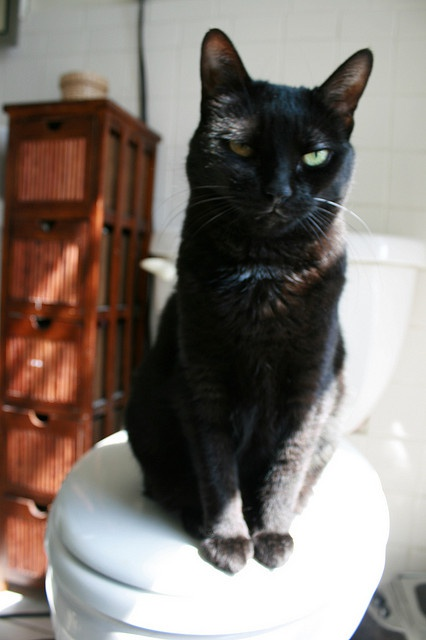Describe the objects in this image and their specific colors. I can see cat in gray, black, lightgray, and darkgray tones and toilet in gray, white, darkgray, and lightblue tones in this image. 